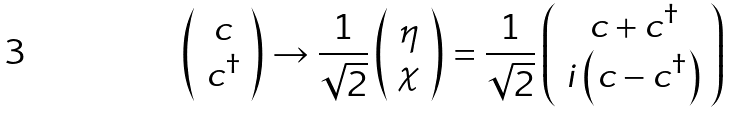<formula> <loc_0><loc_0><loc_500><loc_500>& \left ( \begin{array} { c c } c \\ c ^ { \dag } \\ \end{array} \right ) \to \frac { 1 } { \sqrt { 2 } } \left ( \begin{array} { c c } \eta \\ \chi \end{array} \right ) = \frac { 1 } { \sqrt { 2 } } \left ( \begin{array} { c c } c + c ^ { \dag } \\ { i } \left ( c - c ^ { \dag } \right ) \\ \end{array} \right )</formula> 